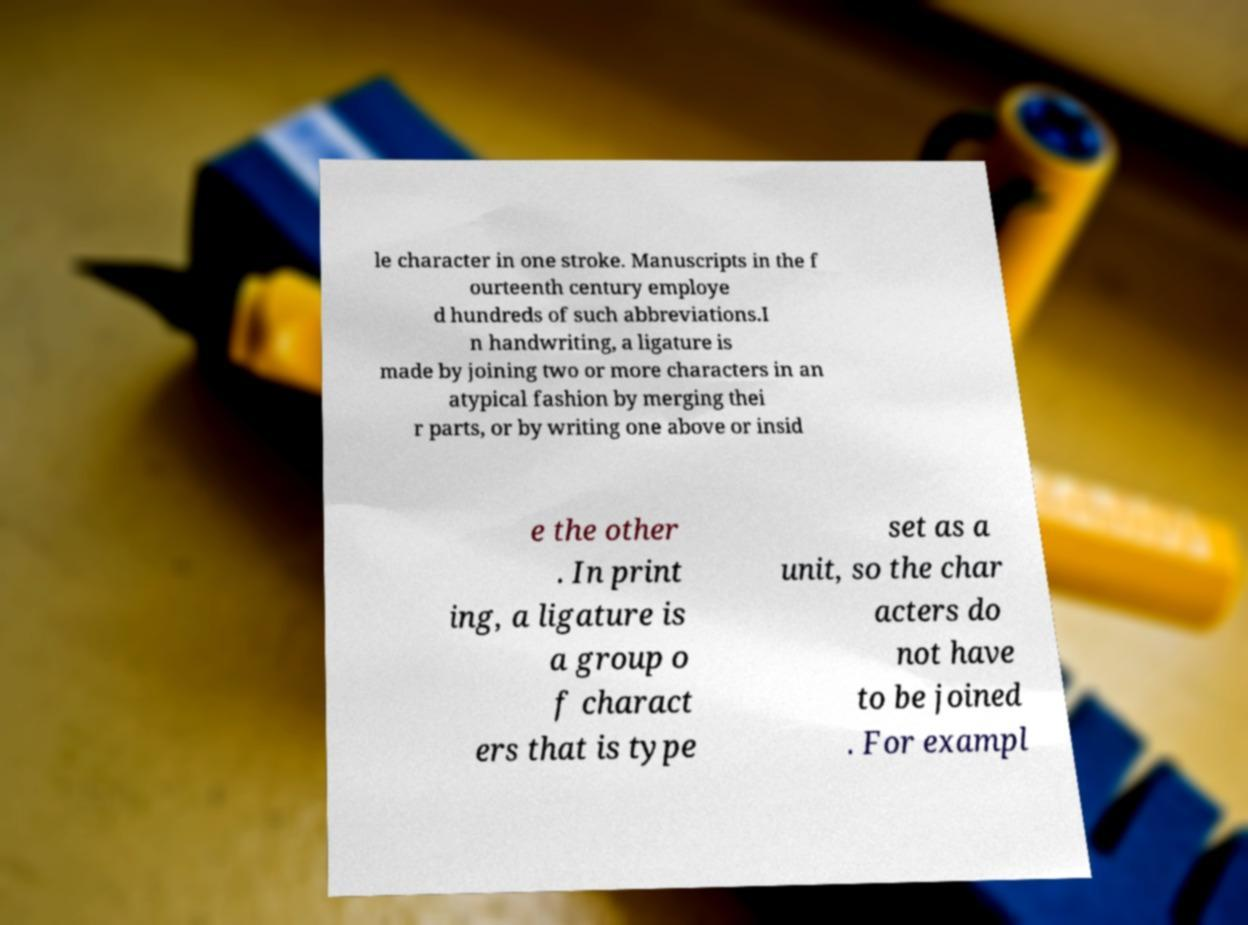Please identify and transcribe the text found in this image. le character in one stroke. Manuscripts in the f ourteenth century employe d hundreds of such abbreviations.I n handwriting, a ligature is made by joining two or more characters in an atypical fashion by merging thei r parts, or by writing one above or insid e the other . In print ing, a ligature is a group o f charact ers that is type set as a unit, so the char acters do not have to be joined . For exampl 